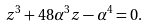Convert formula to latex. <formula><loc_0><loc_0><loc_500><loc_500>z ^ { 3 } + 4 8 \alpha ^ { 3 } z - \alpha ^ { 4 } = 0 .</formula> 